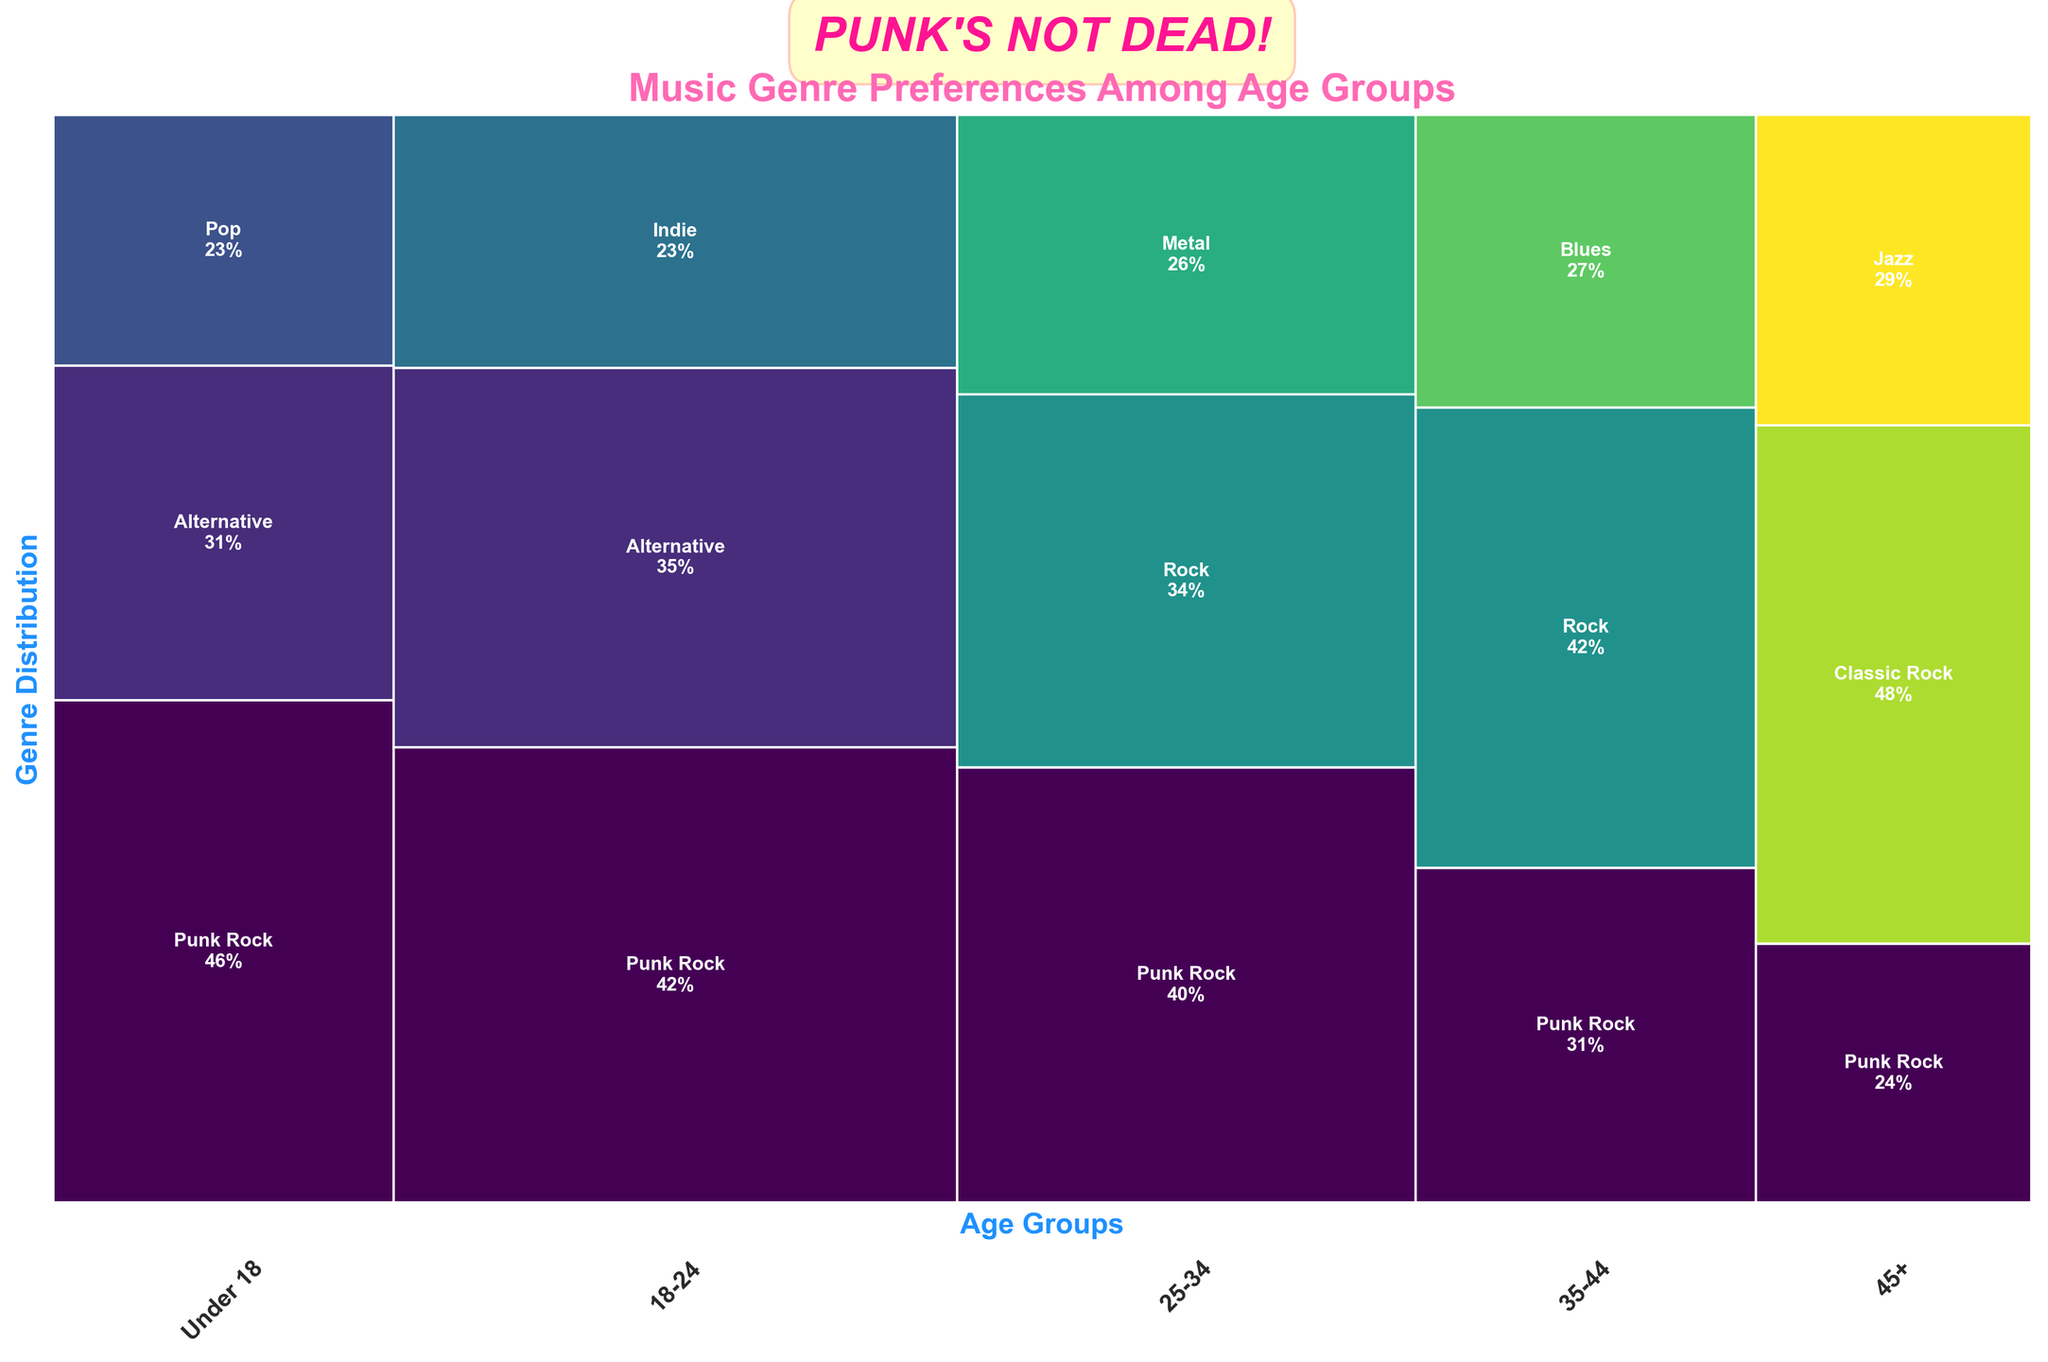What title is displayed on the plot? The title of a plot typically appears at the top and gives an idea of what the data is about. Here, it states the subject of the plot: "Music Genre Preferences Among Age Groups."
Answer: Music Genre Preferences Among Age Groups How is the punk rock genre represented across different age groups? Observe the sections labeled "Punk Rock" in each age group's segment. Notice their height and proportion within each age band's rectangle.
Answer: Most prevalent in 18-24, declines with age Which age group shows the highest preference for Pop music? To find this, locate the segments labeled "Pop" and compare their heights and presence in each age group bar. Pop music only appears within the "Under 18" segment and nowhere else.
Answer: Under 18 What genre is most popular among the 45+ age group? Look at the largest section within the "45+" age group’s bar; it's the one with the largest proportional area.
Answer: Classic Rock Which genre is exclusively present in the 18-24 and 25-34 age groups and not in others? Look for genres that are only found in these two age ranges and not in any young or older age group segments. "Indie” appears only in the 18-24 group and not in any other age bands.
Answer: Indie Compare the Punk Rock preference between the "Under 18" and "25-34" age groups. Identify the sections labeled "Punk Rock" in the "Under 18" and "25-34" segments. Compare their heights and proportions within each group's rectangles. The proportion looks visually comparable, but checking the proportions precisely, "Under 18" has a higher segment, showing its higher popularity.
Answer: Higher in Under 18 Is there any genre completely missing in the "35-44" age group? Inspect the "35-44" segment and see which genres from other age groups are not present within its section. "Pop" and "Indie" sections are absent in "35-44".
Answer: Pop, Indie What age group has the smallest segment for Punk Rock? Compare the relative section sizes of "Punk Rock" in each age group’s bar and identify the smallest.
Answer: 45+ How is Alternative music distributed across age groups? Look for the "Alternative" sections in all age group bars, noting their heights and proportional sizes. It is most prevalent in the 18-24 age group and tapering off in "Under 18."
Answer: Most in 18-24, some in Under 18 